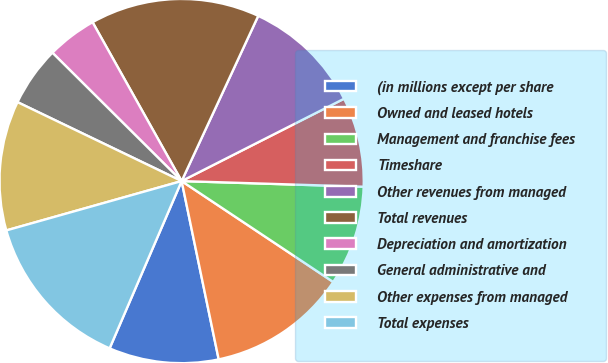Convert chart to OTSL. <chart><loc_0><loc_0><loc_500><loc_500><pie_chart><fcel>(in millions except per share<fcel>Owned and leased hotels<fcel>Management and franchise fees<fcel>Timeshare<fcel>Other revenues from managed<fcel>Total revenues<fcel>Depreciation and amortization<fcel>General administrative and<fcel>Other expenses from managed<fcel>Total expenses<nl><fcel>9.73%<fcel>12.39%<fcel>8.85%<fcel>7.96%<fcel>10.62%<fcel>15.04%<fcel>4.42%<fcel>5.31%<fcel>11.5%<fcel>14.16%<nl></chart> 